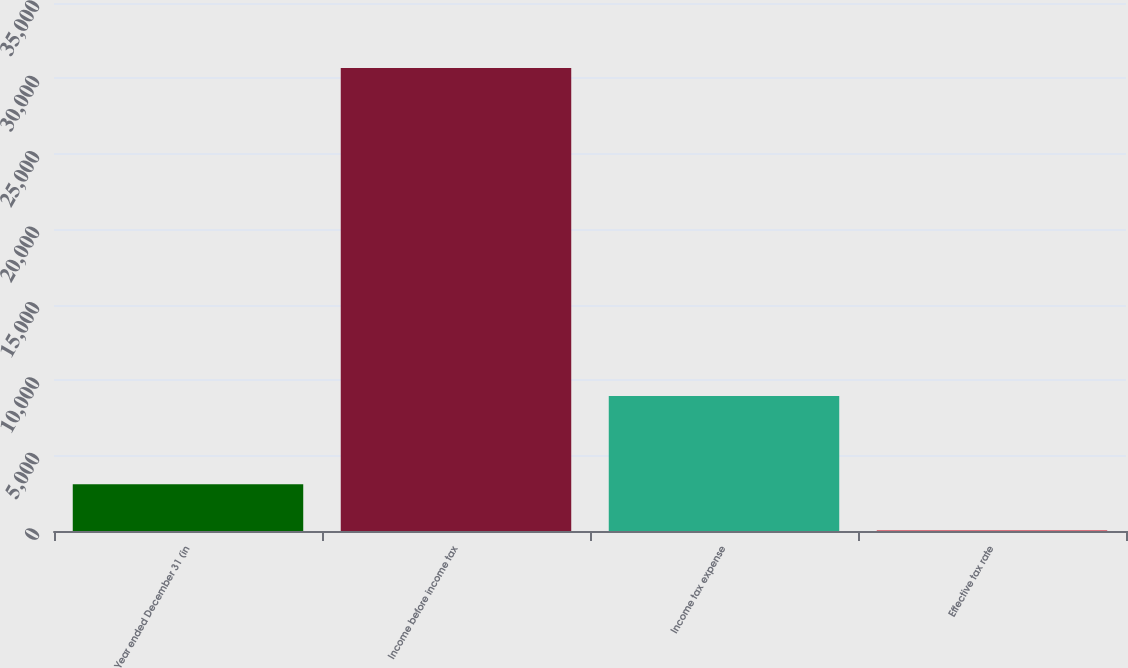Convert chart. <chart><loc_0><loc_0><loc_500><loc_500><bar_chart><fcel>Year ended December 31 (in<fcel>Income before income tax<fcel>Income tax expense<fcel>Effective tax rate<nl><fcel>3096.18<fcel>30699<fcel>8954<fcel>29.2<nl></chart> 